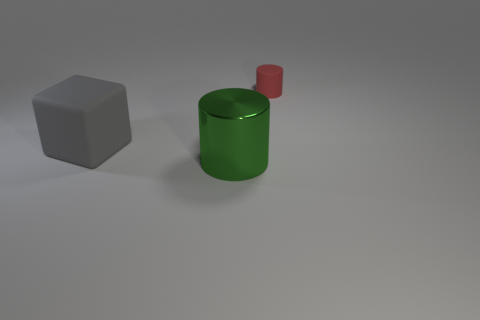Is there any other thing that has the same material as the green object?
Offer a terse response. No. Is the number of green metal cylinders on the right side of the green metallic object less than the number of gray metallic cylinders?
Ensure brevity in your answer.  No. There is a object that is behind the large rubber thing; what is its material?
Your response must be concise. Rubber. How many other objects are the same size as the metal cylinder?
Offer a terse response. 1. Are there fewer red things than small gray rubber cylinders?
Your response must be concise. No. What is the shape of the small red matte thing?
Give a very brief answer. Cylinder. Do the rubber object behind the gray matte object and the large metal cylinder have the same color?
Your response must be concise. No. There is a object that is both to the right of the big gray object and behind the green cylinder; what is its shape?
Offer a terse response. Cylinder. There is a large thing that is to the right of the cube; what color is it?
Provide a short and direct response. Green. Is there anything else of the same color as the large shiny object?
Provide a succinct answer. No. 